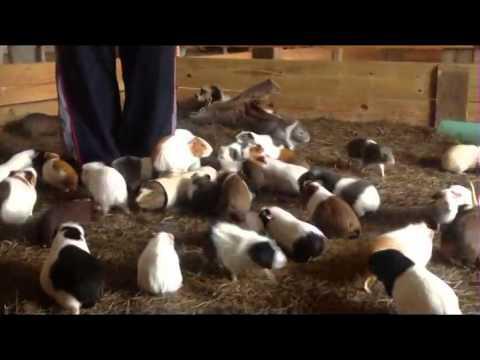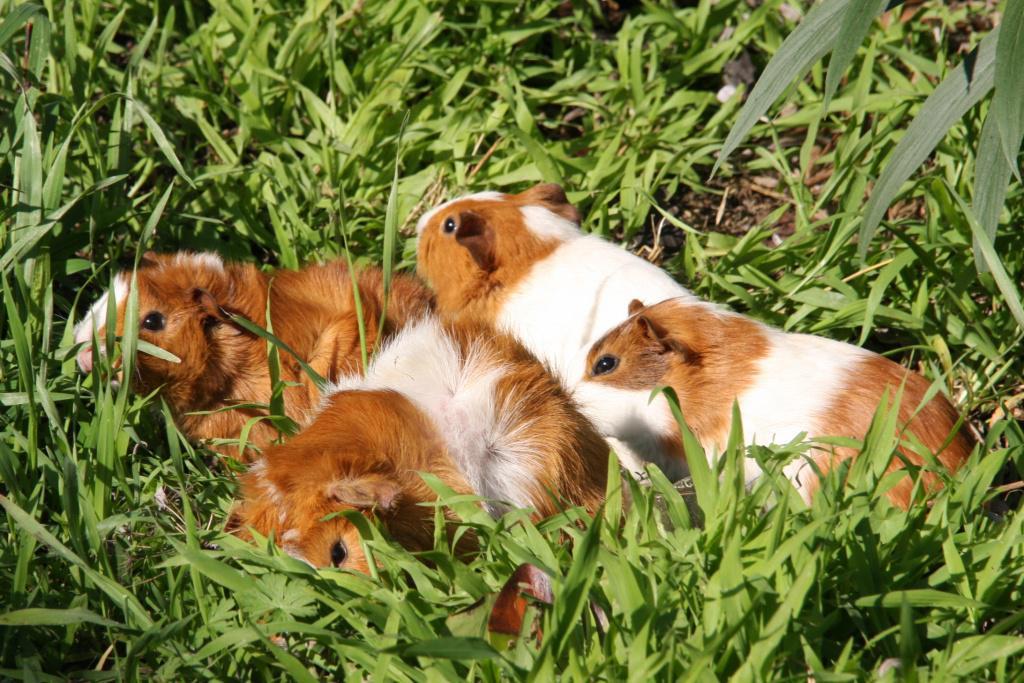The first image is the image on the left, the second image is the image on the right. Given the left and right images, does the statement "One image shows exactly one guinea pig surrounded by butterflies while the other image shows several guinea pigs." hold true? Answer yes or no. No. The first image is the image on the left, the second image is the image on the right. Given the left and right images, does the statement "Multiple hamsters surround a pile of leafy greens in at least one image." hold true? Answer yes or no. No. 